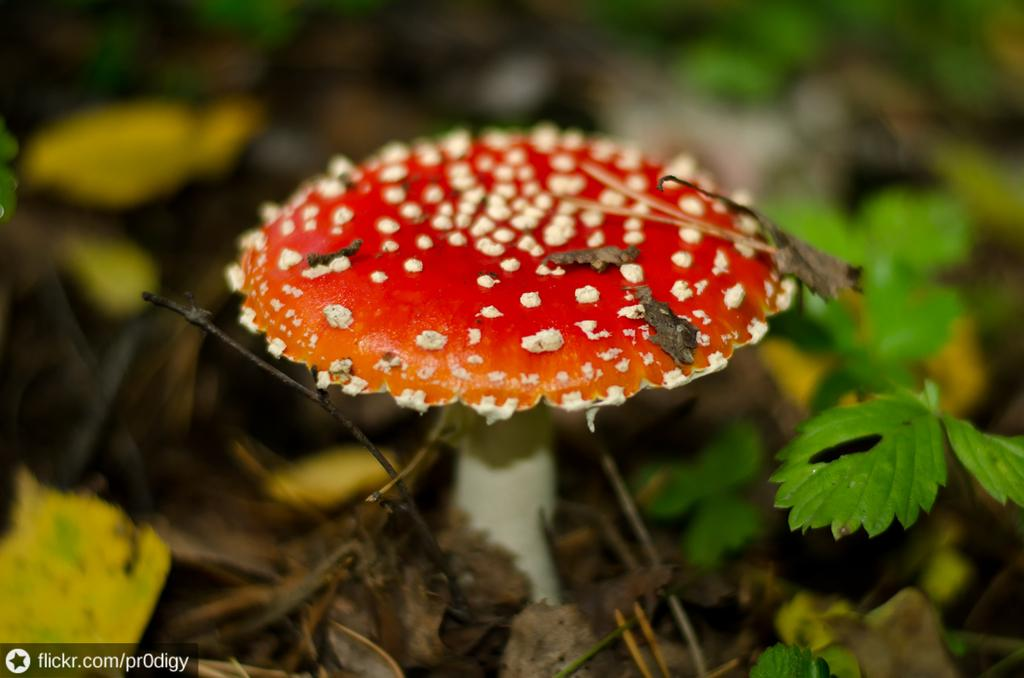What is the main subject of the image? There is a mushroom in the image. What else can be seen in the image besides the mushroom? There are many dry leaves and a few plants in the image. How many sailboats are visible in the image? There are no sailboats present in the image; it features a mushroom, dry leaves, and a few plants. What type of brass object can be seen in the image? There is no brass object present in the image. 